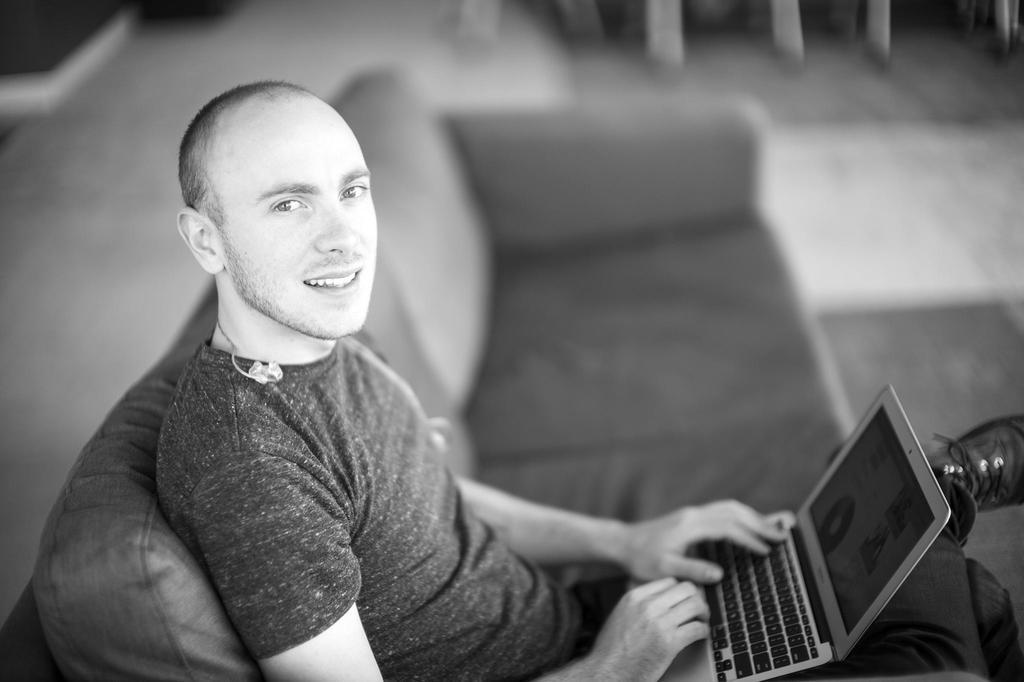What is the color scheme of the image? The image is black and white. What is the person in the image doing? The person is sitting on a sofa and holding a laptop on their lap. Can you describe the background of the image? The background of the image is blurred. What type of shoes is the person wearing in the image? There is no information about shoes in the image, as it is black and white and focuses on the person sitting on a sofa with a laptop. 